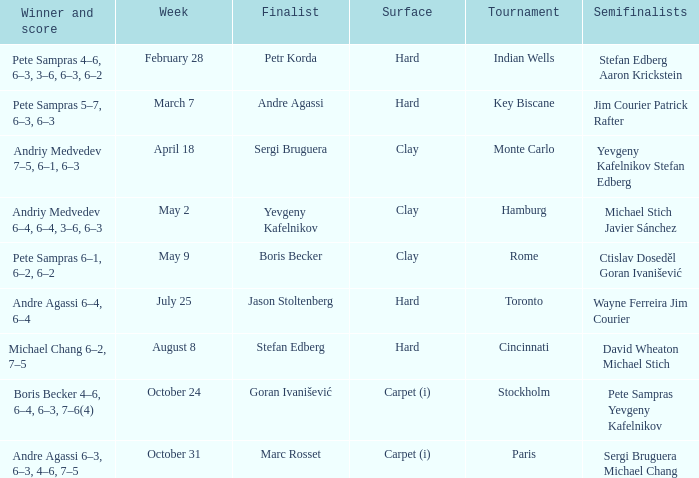Who was the semifinalist for the key biscane tournament? Jim Courier Patrick Rafter. 